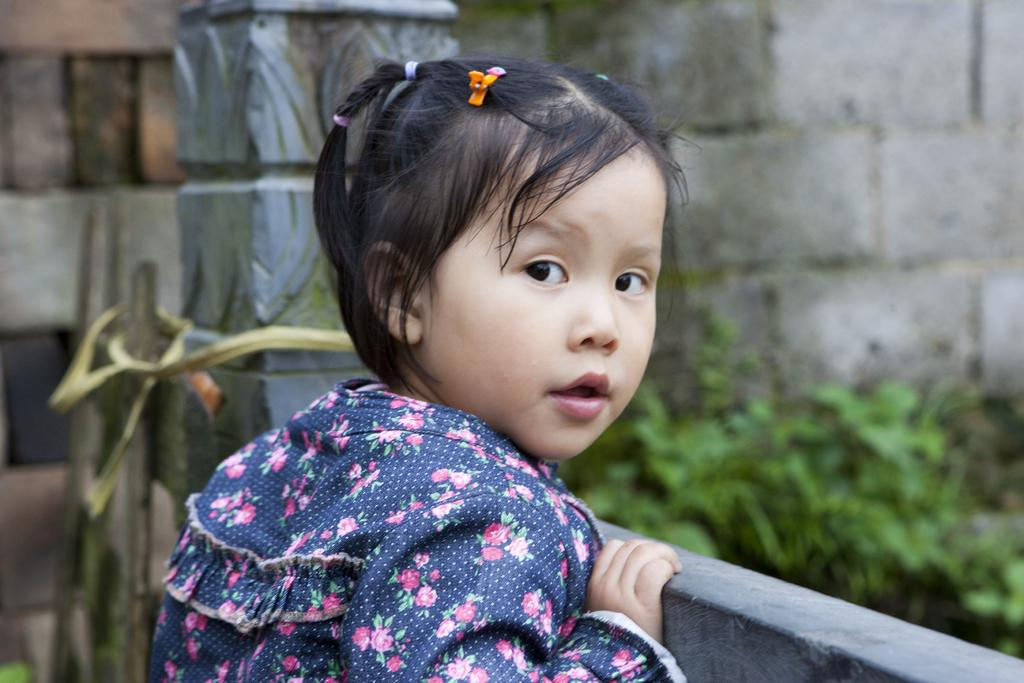Who is the main subject in the image? There is a girl in the image. What can be seen in the background of the image? There is a wall and plants in the background of the image. What type of sweater is the girl wearing during the earthquake in the image? There is no sweater or earthquake present in the image; it only features a girl and a background with a wall and plants. 